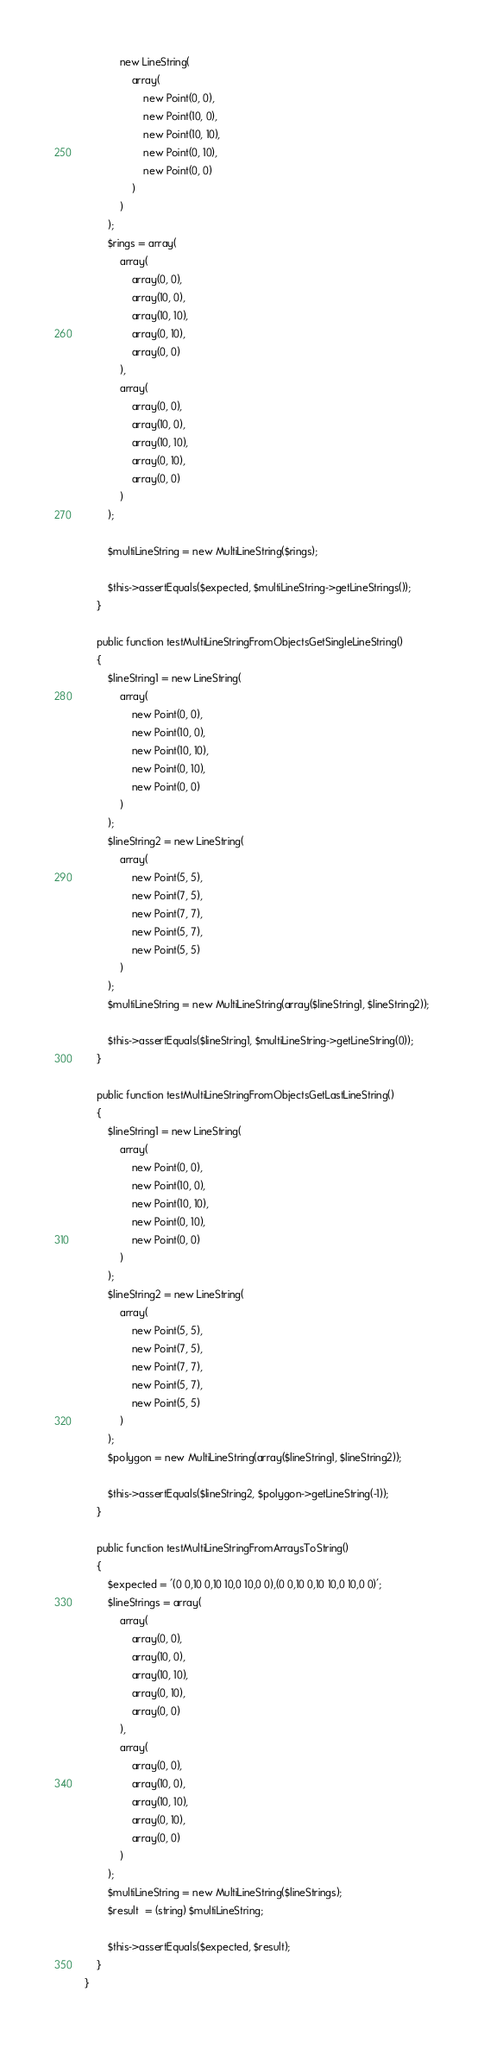Convert code to text. <code><loc_0><loc_0><loc_500><loc_500><_PHP_>            new LineString(
                array(
                    new Point(0, 0),
                    new Point(10, 0),
                    new Point(10, 10),
                    new Point(0, 10),
                    new Point(0, 0)
                )
            )
        );
        $rings = array(
            array(
                array(0, 0),
                array(10, 0),
                array(10, 10),
                array(0, 10),
                array(0, 0)
            ),
            array(
                array(0, 0),
                array(10, 0),
                array(10, 10),
                array(0, 10),
                array(0, 0)
            )
        );

        $multiLineString = new MultiLineString($rings);

        $this->assertEquals($expected, $multiLineString->getLineStrings());
    }

    public function testMultiLineStringFromObjectsGetSingleLineString()
    {
        $lineString1 = new LineString(
            array(
                new Point(0, 0),
                new Point(10, 0),
                new Point(10, 10),
                new Point(0, 10),
                new Point(0, 0)
            )
        );
        $lineString2 = new LineString(
            array(
                new Point(5, 5),
                new Point(7, 5),
                new Point(7, 7),
                new Point(5, 7),
                new Point(5, 5)
            )
        );
        $multiLineString = new MultiLineString(array($lineString1, $lineString2));

        $this->assertEquals($lineString1, $multiLineString->getLineString(0));
    }

    public function testMultiLineStringFromObjectsGetLastLineString()
    {
        $lineString1 = new LineString(
            array(
                new Point(0, 0),
                new Point(10, 0),
                new Point(10, 10),
                new Point(0, 10),
                new Point(0, 0)
            )
        );
        $lineString2 = new LineString(
            array(
                new Point(5, 5),
                new Point(7, 5),
                new Point(7, 7),
                new Point(5, 7),
                new Point(5, 5)
            )
        );
        $polygon = new MultiLineString(array($lineString1, $lineString2));

        $this->assertEquals($lineString2, $polygon->getLineString(-1));
    }

    public function testMultiLineStringFromArraysToString()
    {
        $expected = '(0 0,10 0,10 10,0 10,0 0),(0 0,10 0,10 10,0 10,0 0)';
        $lineStrings = array(
            array(
                array(0, 0),
                array(10, 0),
                array(10, 10),
                array(0, 10),
                array(0, 0)
            ),
            array(
                array(0, 0),
                array(10, 0),
                array(10, 10),
                array(0, 10),
                array(0, 0)
            )
        );
        $multiLineString = new MultiLineString($lineStrings);
        $result  = (string) $multiLineString;

        $this->assertEquals($expected, $result);
    }
}
</code> 